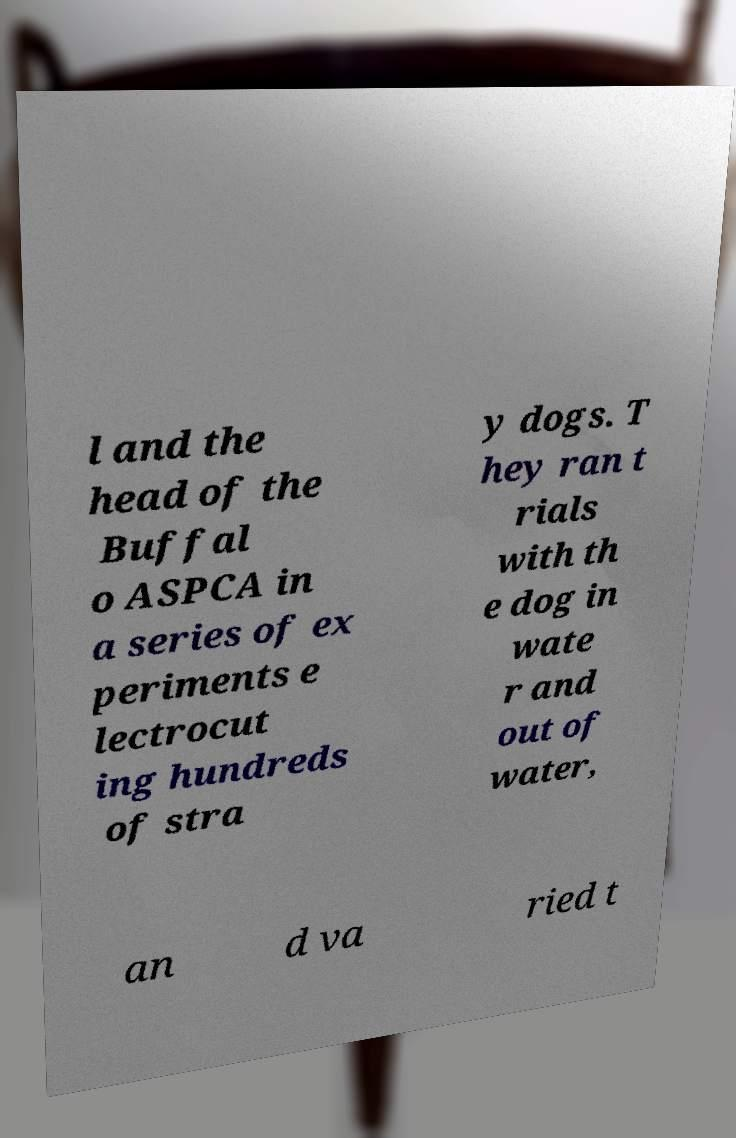I need the written content from this picture converted into text. Can you do that? l and the head of the Buffal o ASPCA in a series of ex periments e lectrocut ing hundreds of stra y dogs. T hey ran t rials with th e dog in wate r and out of water, an d va ried t 